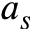Convert formula to latex. <formula><loc_0><loc_0><loc_500><loc_500>a _ { s }</formula> 